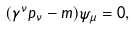Convert formula to latex. <formula><loc_0><loc_0><loc_500><loc_500>( \gamma ^ { \nu } p _ { \nu } - m ) \psi _ { \mu } = 0 ,</formula> 